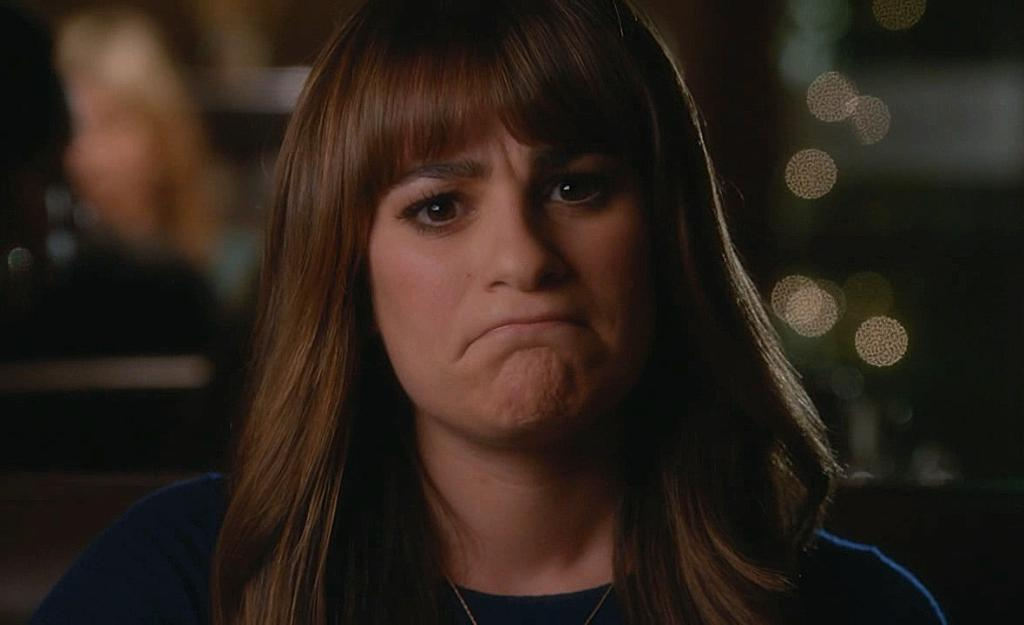What is the main subject of the image? There is a woman in the image. Can you describe the background of the image? The background of the image is blurred. What type of paint is the woman using in the image? There is no paint or painting activity present in the image. What type of school is the woman attending in the image? There is no indication of a school or educational setting in the image. 